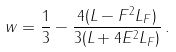Convert formula to latex. <formula><loc_0><loc_0><loc_500><loc_500>w = \frac { 1 } { 3 } - \frac { 4 ( L - F ^ { 2 } L _ { F } ) } { 3 ( L + 4 E ^ { 2 } L _ { F } ) } \, .</formula> 